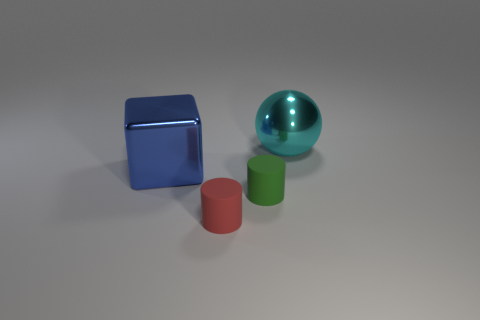The object that is the same size as the metallic block is what shape?
Provide a succinct answer. Sphere. Are there more red cylinders than large blue shiny balls?
Keep it short and to the point. Yes. Is there a small red rubber thing right of the small rubber thing that is in front of the green cylinder?
Make the answer very short. No. There is another small matte object that is the same shape as the small green rubber object; what color is it?
Ensure brevity in your answer.  Red. Are there any other things that are the same shape as the green object?
Your response must be concise. Yes. The big thing that is the same material as the cyan sphere is what color?
Your response must be concise. Blue. Is there a tiny red cylinder behind the tiny cylinder that is behind the cylinder that is on the left side of the green rubber thing?
Keep it short and to the point. No. Is the number of blue shiny objects that are behind the small green matte thing less than the number of large metallic blocks that are on the right side of the big block?
Keep it short and to the point. No. How many other cylinders are made of the same material as the green cylinder?
Your answer should be very brief. 1. There is a blue block; is its size the same as the cyan ball on the right side of the tiny green object?
Offer a very short reply. Yes. 